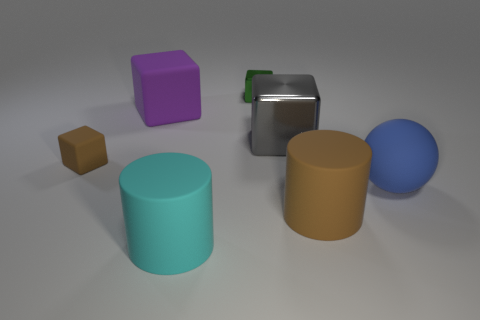What number of objects are either tiny brown matte cubes or purple rubber cubes?
Give a very brief answer. 2. Are the tiny brown block and the tiny thing that is to the right of the brown block made of the same material?
Ensure brevity in your answer.  No. Are there any other things that are the same color as the big rubber cube?
Provide a short and direct response. No. What number of things are brown matte things left of the big purple object or things behind the tiny brown matte block?
Ensure brevity in your answer.  4. What shape is the large matte object that is both in front of the rubber sphere and right of the green metallic thing?
Provide a succinct answer. Cylinder. There is a tiny cube that is on the left side of the cyan object; what number of gray cubes are behind it?
Your response must be concise. 1. Are there any other things that are made of the same material as the brown cylinder?
Your answer should be compact. Yes. What number of things are big cyan cylinders that are to the right of the brown block or large matte cylinders?
Your answer should be compact. 2. How big is the rubber cylinder that is on the left side of the large brown matte thing?
Give a very brief answer. Large. What material is the blue thing?
Give a very brief answer. Rubber. 